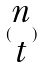<formula> <loc_0><loc_0><loc_500><loc_500>( \begin{matrix} n \\ t \end{matrix} )</formula> 